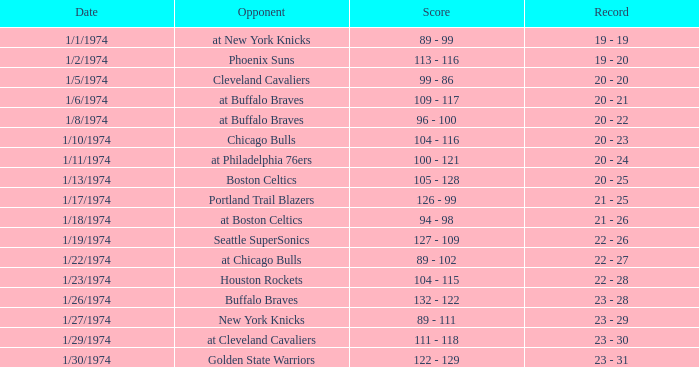What was the outcome post game 51 on 1/27/1974? 23 - 29. 